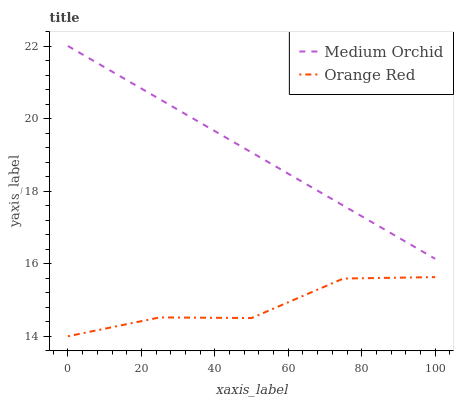Does Orange Red have the minimum area under the curve?
Answer yes or no. Yes. Does Medium Orchid have the maximum area under the curve?
Answer yes or no. Yes. Does Orange Red have the maximum area under the curve?
Answer yes or no. No. Is Medium Orchid the smoothest?
Answer yes or no. Yes. Is Orange Red the roughest?
Answer yes or no. Yes. Is Orange Red the smoothest?
Answer yes or no. No. Does Orange Red have the lowest value?
Answer yes or no. Yes. Does Medium Orchid have the highest value?
Answer yes or no. Yes. Does Orange Red have the highest value?
Answer yes or no. No. Is Orange Red less than Medium Orchid?
Answer yes or no. Yes. Is Medium Orchid greater than Orange Red?
Answer yes or no. Yes. Does Orange Red intersect Medium Orchid?
Answer yes or no. No. 